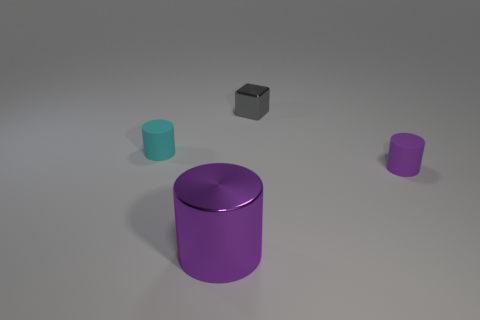There is a tiny thing that is the same color as the big object; what material is it?
Your answer should be very brief. Rubber. How many small blue rubber balls are there?
Offer a very short reply. 0. What number of small things are on the right side of the cyan matte cylinder and behind the tiny purple cylinder?
Your answer should be compact. 1. Is there a small cyan thing that has the same material as the tiny cyan cylinder?
Keep it short and to the point. No. The cylinder on the left side of the purple metal object left of the gray object is made of what material?
Ensure brevity in your answer.  Rubber. Is the number of big shiny cylinders behind the tiny purple matte object the same as the number of large purple objects in front of the large shiny thing?
Provide a short and direct response. Yes. Is the shape of the tiny cyan object the same as the gray thing?
Offer a terse response. No. What material is the object that is behind the small purple object and left of the gray shiny block?
Offer a very short reply. Rubber. What number of other cyan things are the same shape as the big shiny object?
Make the answer very short. 1. What is the size of the purple rubber cylinder right of the tiny thing behind the small matte object that is behind the tiny purple object?
Offer a very short reply. Small. 